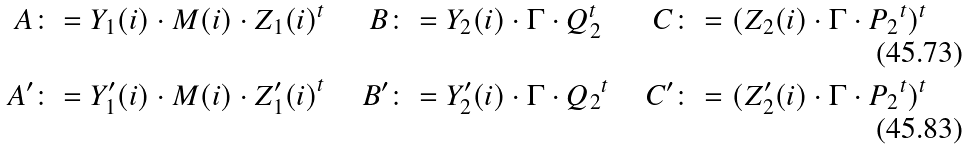Convert formula to latex. <formula><loc_0><loc_0><loc_500><loc_500>A & \colon = Y _ { 1 } ( i ) \cdot M ( i ) \cdot Z _ { 1 } ( i ) ^ { t } & B & \colon = Y _ { 2 } ( i ) \cdot \Gamma \cdot Q _ { 2 } ^ { t } & C & \colon = ( Z _ { 2 } ( i ) \cdot \Gamma \cdot { P _ { 2 } } ^ { t } ) ^ { t } \\ A ^ { \prime } & \colon = Y ^ { \prime } _ { 1 } ( i ) \cdot M ( i ) \cdot { Z ^ { \prime } _ { 1 } ( i ) } ^ { t } & B ^ { \prime } & \colon = Y ^ { \prime } _ { 2 } ( i ) \cdot \Gamma \cdot { Q _ { 2 } } ^ { t } & C ^ { \prime } & \colon = ( Z ^ { \prime } _ { 2 } ( i ) \cdot \Gamma \cdot { P _ { 2 } } ^ { t } ) ^ { t }</formula> 